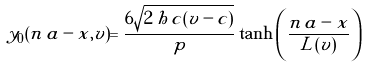<formula> <loc_0><loc_0><loc_500><loc_500>y _ { 0 } ( n \, a - x , v ) = \frac { 6 \sqrt { 2 \, h \, c ( v - c ) } } { p } \tanh \left ( \frac { n \, a - x } { L ( v ) } \right )</formula> 